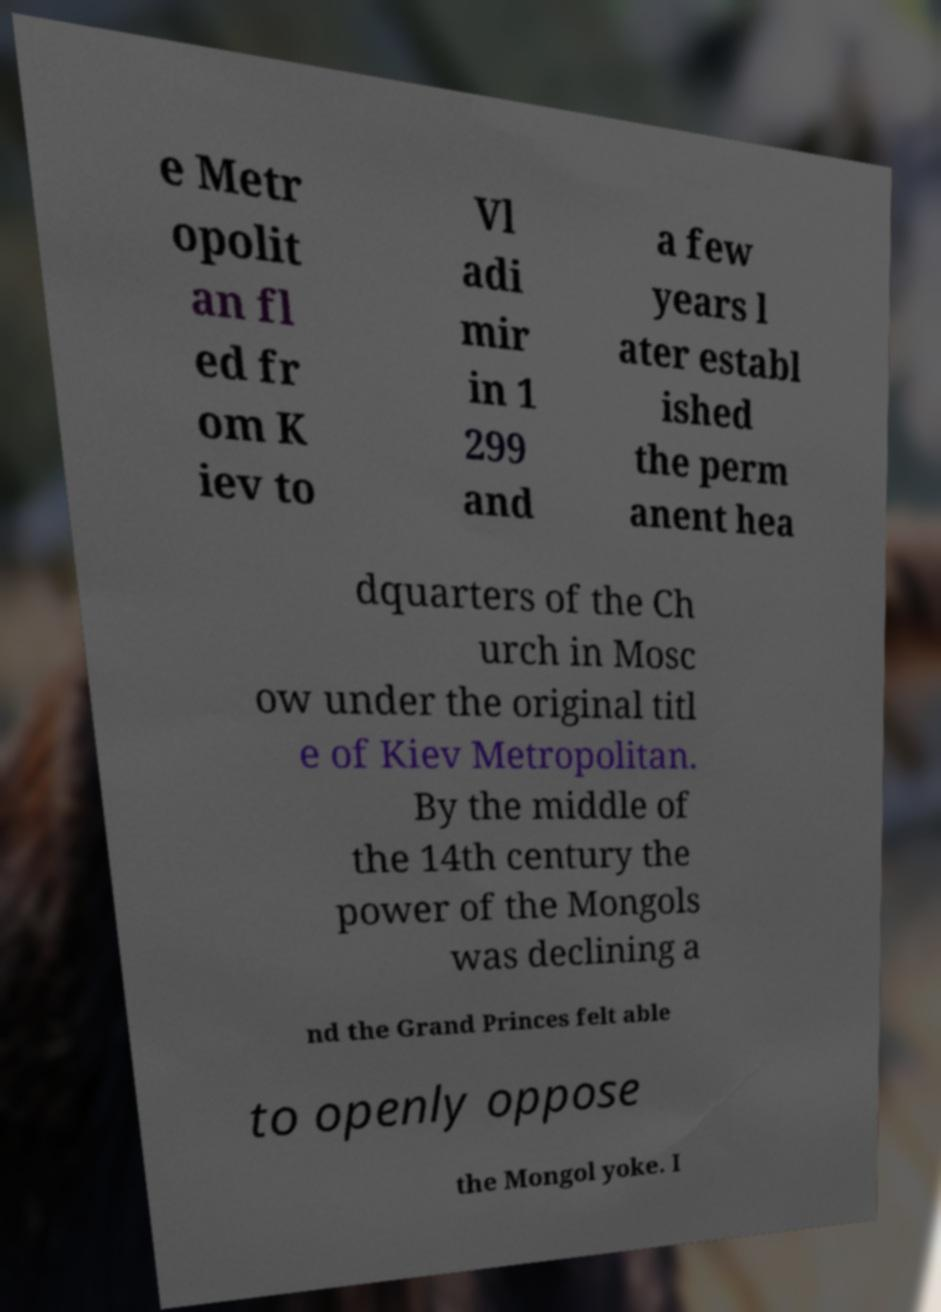What messages or text are displayed in this image? I need them in a readable, typed format. e Metr opolit an fl ed fr om K iev to Vl adi mir in 1 299 and a few years l ater establ ished the perm anent hea dquarters of the Ch urch in Mosc ow under the original titl e of Kiev Metropolitan. By the middle of the 14th century the power of the Mongols was declining a nd the Grand Princes felt able to openly oppose the Mongol yoke. I 